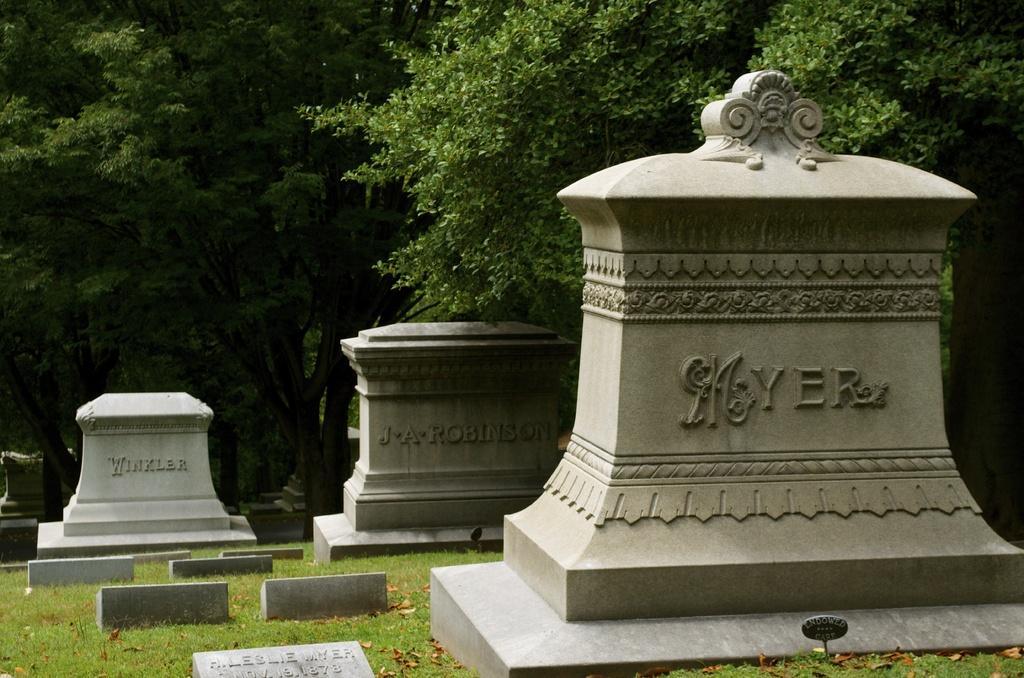Could you give a brief overview of what you see in this image? In the foreground of this picture, there are few headstones and in the background, there are trees. 